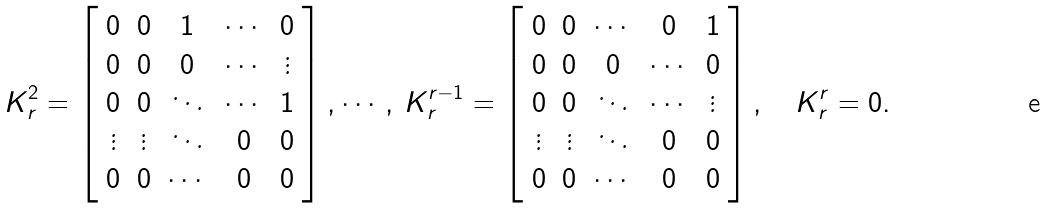Convert formula to latex. <formula><loc_0><loc_0><loc_500><loc_500>K _ { r } ^ { 2 } = \left [ \begin{array} { c c c c c } 0 & 0 & 1 & \cdots & 0 \\ 0 & 0 & 0 & \cdots & \vdots \\ 0 & 0 & \ddots & \cdots & 1 \\ \vdots & \vdots & \ddots & 0 & 0 \\ 0 & 0 & \cdots & 0 & 0 \end{array} \right ] , \cdots , \, K _ { r } ^ { r - 1 } = \left [ \begin{array} { c c c c c } 0 & 0 & \cdots & 0 & 1 \\ 0 & 0 & 0 & \cdots & 0 \\ 0 & 0 & \ddots & \cdots & \vdots \\ \vdots & \vdots & \ddots & 0 & 0 \\ 0 & 0 & \cdots & 0 & 0 \end{array} \right ] , \quad K _ { r } ^ { r } = 0 .</formula> 